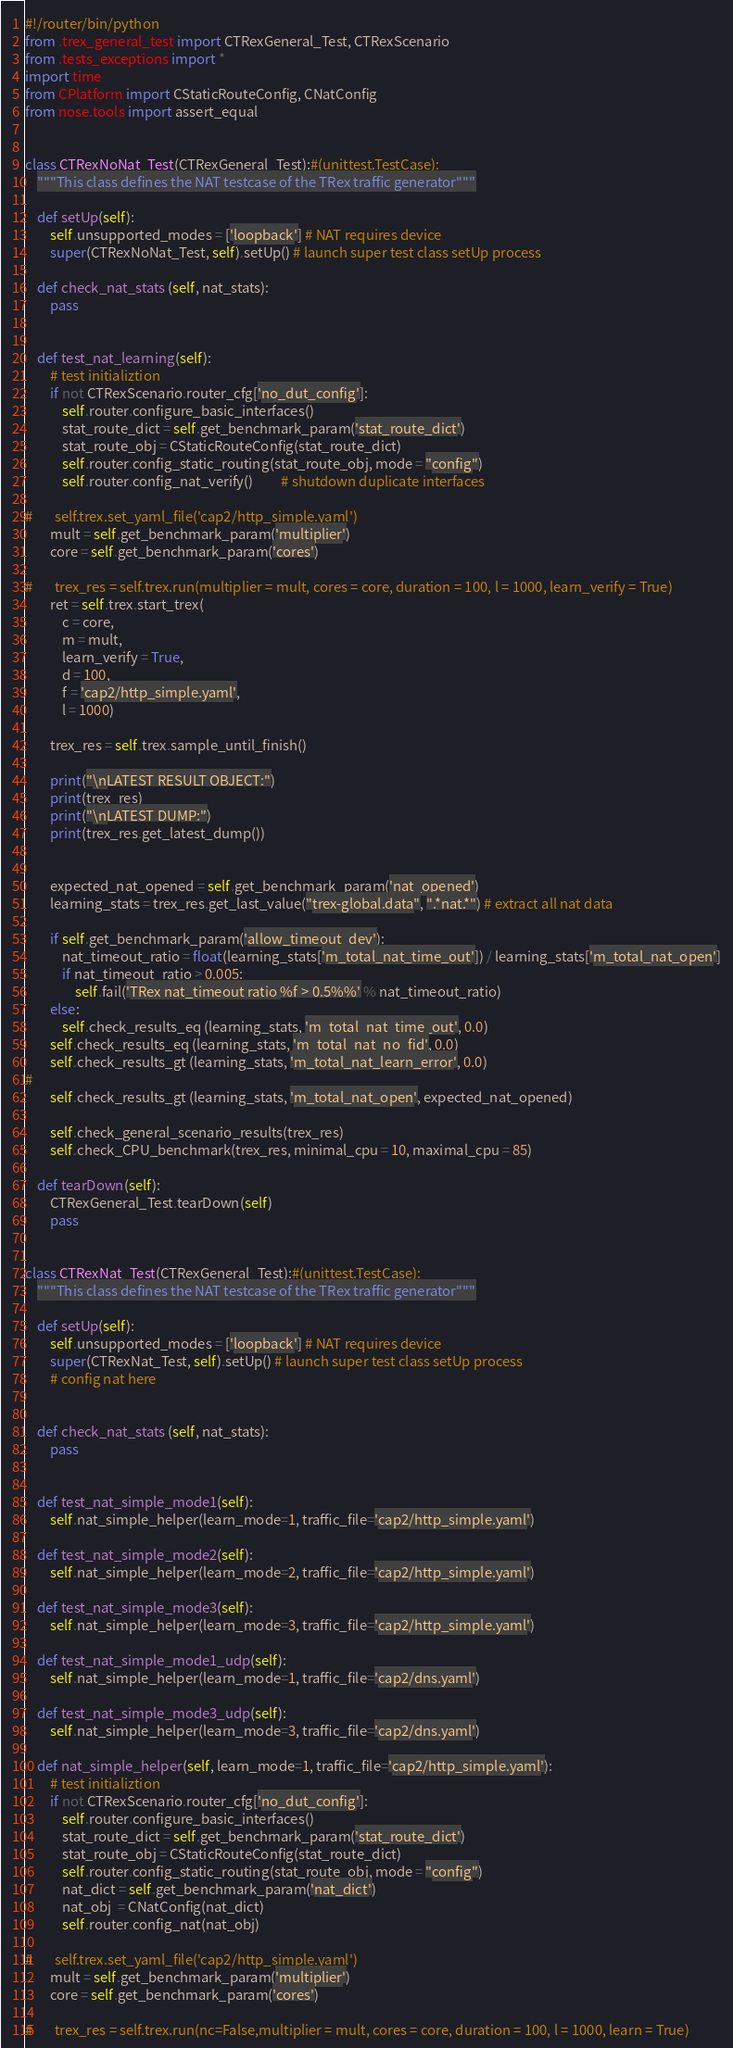<code> <loc_0><loc_0><loc_500><loc_500><_Python_>#!/router/bin/python
from .trex_general_test import CTRexGeneral_Test, CTRexScenario
from .tests_exceptions import *
import time
from CPlatform import CStaticRouteConfig, CNatConfig
from nose.tools import assert_equal


class CTRexNoNat_Test(CTRexGeneral_Test):#(unittest.TestCase):
    """This class defines the NAT testcase of the TRex traffic generator"""

    def setUp(self):
        self.unsupported_modes = ['loopback'] # NAT requires device
        super(CTRexNoNat_Test, self).setUp() # launch super test class setUp process

    def check_nat_stats (self, nat_stats):
        pass


    def test_nat_learning(self):
        # test initializtion
        if not CTRexScenario.router_cfg['no_dut_config']:
            self.router.configure_basic_interfaces()
            stat_route_dict = self.get_benchmark_param('stat_route_dict')
            stat_route_obj = CStaticRouteConfig(stat_route_dict)
            self.router.config_static_routing(stat_route_obj, mode = "config")
            self.router.config_nat_verify()         # shutdown duplicate interfaces

#       self.trex.set_yaml_file('cap2/http_simple.yaml')
        mult = self.get_benchmark_param('multiplier')
        core = self.get_benchmark_param('cores')

#       trex_res = self.trex.run(multiplier = mult, cores = core, duration = 100, l = 1000, learn_verify = True)
        ret = self.trex.start_trex(
            c = core,
            m = mult,
            learn_verify = True,
            d = 100,   
            f = 'cap2/http_simple.yaml',
            l = 1000)

        trex_res = self.trex.sample_until_finish()

        print("\nLATEST RESULT OBJECT:")
        print(trex_res)
        print("\nLATEST DUMP:")
        print(trex_res.get_latest_dump())


        expected_nat_opened = self.get_benchmark_param('nat_opened')
        learning_stats = trex_res.get_last_value("trex-global.data", ".*nat.*") # extract all nat data

        if self.get_benchmark_param('allow_timeout_dev'):
            nat_timeout_ratio = float(learning_stats['m_total_nat_time_out']) / learning_stats['m_total_nat_open']
            if nat_timeout_ratio > 0.005:
                self.fail('TRex nat_timeout ratio %f > 0.5%%' % nat_timeout_ratio)
        else:
            self.check_results_eq (learning_stats, 'm_total_nat_time_out', 0.0)
        self.check_results_eq (learning_stats, 'm_total_nat_no_fid', 0.0)
        self.check_results_gt (learning_stats, 'm_total_nat_learn_error', 0.0)
#
        self.check_results_gt (learning_stats, 'm_total_nat_open', expected_nat_opened)

        self.check_general_scenario_results(trex_res)
        self.check_CPU_benchmark(trex_res, minimal_cpu = 10, maximal_cpu = 85)

    def tearDown(self):
        CTRexGeneral_Test.tearDown(self)
        pass


class CTRexNat_Test(CTRexGeneral_Test):#(unittest.TestCase):
    """This class defines the NAT testcase of the TRex traffic generator"""

    def setUp(self):
        self.unsupported_modes = ['loopback'] # NAT requires device
        super(CTRexNat_Test, self).setUp() # launch super test class setUp process
        # config nat here
        

    def check_nat_stats (self, nat_stats):
        pass


    def test_nat_simple_mode1(self):
        self.nat_simple_helper(learn_mode=1, traffic_file='cap2/http_simple.yaml')

    def test_nat_simple_mode2(self):
        self.nat_simple_helper(learn_mode=2, traffic_file='cap2/http_simple.yaml')

    def test_nat_simple_mode3(self):
        self.nat_simple_helper(learn_mode=3, traffic_file='cap2/http_simple.yaml')

    def test_nat_simple_mode1_udp(self):
        self.nat_simple_helper(learn_mode=1, traffic_file='cap2/dns.yaml')

    def test_nat_simple_mode3_udp(self):
        self.nat_simple_helper(learn_mode=3, traffic_file='cap2/dns.yaml')

    def nat_simple_helper(self, learn_mode=1, traffic_file='cap2/http_simple.yaml'):
        # test initializtion
        if not CTRexScenario.router_cfg['no_dut_config']:
            self.router.configure_basic_interfaces()
            stat_route_dict = self.get_benchmark_param('stat_route_dict')
            stat_route_obj = CStaticRouteConfig(stat_route_dict)
            self.router.config_static_routing(stat_route_obj, mode = "config")
            nat_dict = self.get_benchmark_param('nat_dict')
            nat_obj  = CNatConfig(nat_dict)
            self.router.config_nat(nat_obj)

#       self.trex.set_yaml_file('cap2/http_simple.yaml')
        mult = self.get_benchmark_param('multiplier')
        core = self.get_benchmark_param('cores')

#       trex_res = self.trex.run(nc=False,multiplier = mult, cores = core, duration = 100, l = 1000, learn = True)</code> 